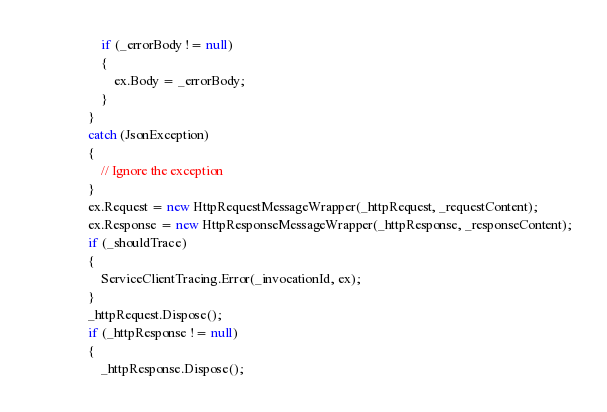<code> <loc_0><loc_0><loc_500><loc_500><_C#_>                    if (_errorBody != null)
                    {
                        ex.Body = _errorBody;
                    }
                }
                catch (JsonException)
                {
                    // Ignore the exception
                }
                ex.Request = new HttpRequestMessageWrapper(_httpRequest, _requestContent);
                ex.Response = new HttpResponseMessageWrapper(_httpResponse, _responseContent);
                if (_shouldTrace)
                {
                    ServiceClientTracing.Error(_invocationId, ex);
                }
                _httpRequest.Dispose();
                if (_httpResponse != null)
                {
                    _httpResponse.Dispose();</code> 